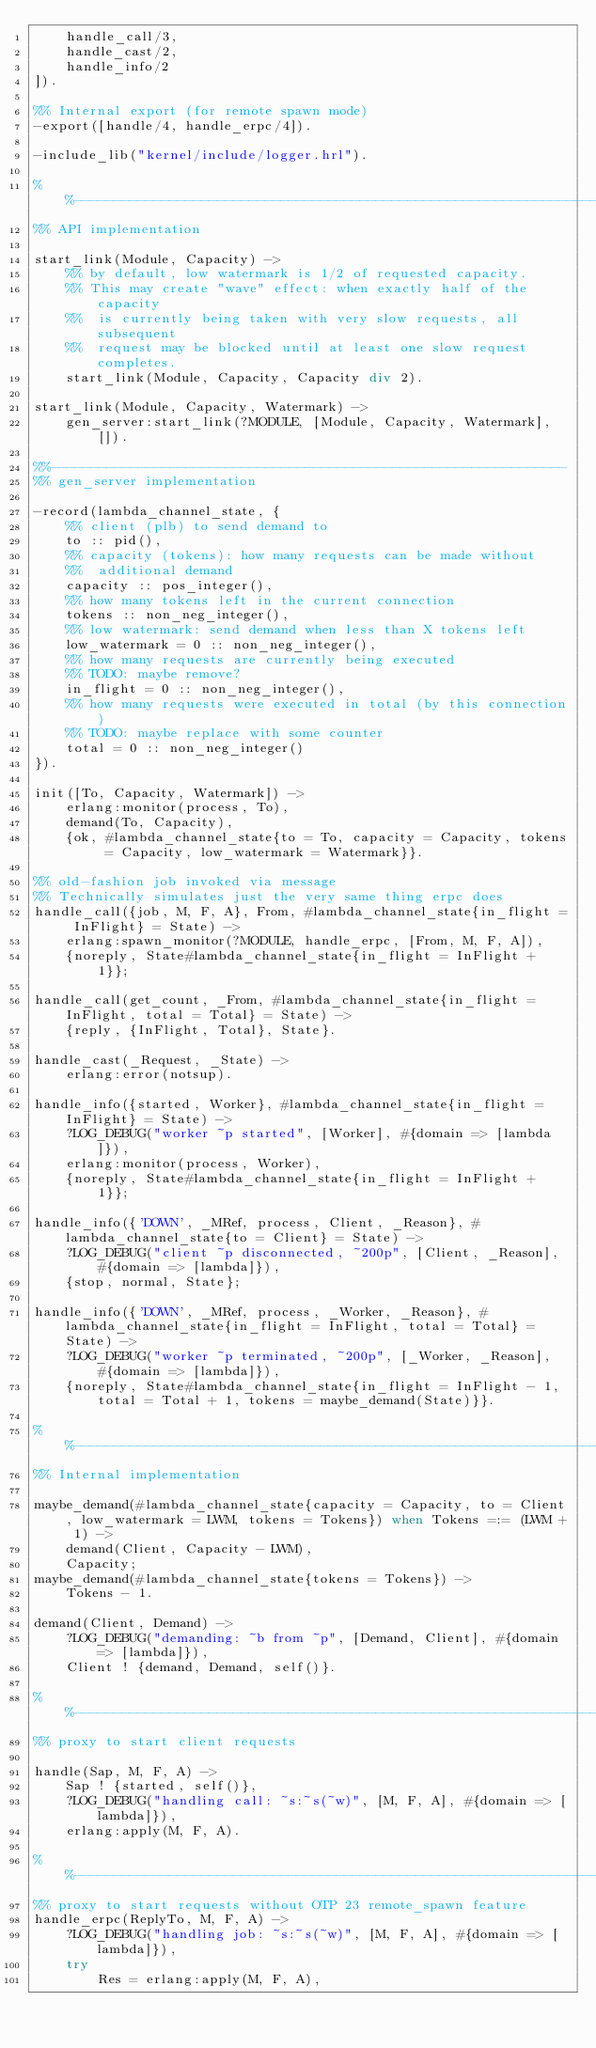<code> <loc_0><loc_0><loc_500><loc_500><_Erlang_>    handle_call/3,
    handle_cast/2,
    handle_info/2
]).

%% Internal export (for remote spawn mode)
-export([handle/4, handle_erpc/4]).

-include_lib("kernel/include/logger.hrl").

%%--------------------------------------------------------------------
%% API implementation

start_link(Module, Capacity) ->
    %% by default, low watermark is 1/2 of requested capacity.
    %% This may create "wave" effect: when exactly half of the capacity
    %%  is currently being taken with very slow requests, all subsequent
    %%  request may be blocked until at least one slow request completes.
    start_link(Module, Capacity, Capacity div 2).

start_link(Module, Capacity, Watermark) ->
    gen_server:start_link(?MODULE, [Module, Capacity, Watermark], []).

%%-----------------------------------------------------------------
%% gen_server implementation

-record(lambda_channel_state, {
    %% client (plb) to send demand to
    to :: pid(),
    %% capacity (tokens): how many requests can be made without
    %%  additional demand
    capacity :: pos_integer(),
    %% how many tokens left in the current connection
    tokens :: non_neg_integer(),
    %% low watermark: send demand when less than X tokens left
    low_watermark = 0 :: non_neg_integer(),
    %% how many requests are currently being executed
    %% TODO: maybe remove?
    in_flight = 0 :: non_neg_integer(),
    %% how many requests were executed in total (by this connection)
    %% TODO: maybe replace with some counter
    total = 0 :: non_neg_integer()
}).

init([To, Capacity, Watermark]) ->
    erlang:monitor(process, To),
    demand(To, Capacity),
    {ok, #lambda_channel_state{to = To, capacity = Capacity, tokens = Capacity, low_watermark = Watermark}}.

%% old-fashion job invoked via message
%% Technically simulates just the very same thing erpc does
handle_call({job, M, F, A}, From, #lambda_channel_state{in_flight = InFlight} = State) ->
    erlang:spawn_monitor(?MODULE, handle_erpc, [From, M, F, A]),
    {noreply, State#lambda_channel_state{in_flight = InFlight + 1}};

handle_call(get_count, _From, #lambda_channel_state{in_flight = InFlight, total = Total} = State) ->
    {reply, {InFlight, Total}, State}.

handle_cast(_Request, _State) ->
    erlang:error(notsup).

handle_info({started, Worker}, #lambda_channel_state{in_flight = InFlight} = State) ->
    ?LOG_DEBUG("worker ~p started", [Worker], #{domain => [lambda]}),
    erlang:monitor(process, Worker),
    {noreply, State#lambda_channel_state{in_flight = InFlight + 1}};

handle_info({'DOWN', _MRef, process, Client, _Reason}, #lambda_channel_state{to = Client} = State) ->
    ?LOG_DEBUG("client ~p disconnected, ~200p", [Client, _Reason], #{domain => [lambda]}),
    {stop, normal, State};

handle_info({'DOWN', _MRef, process, _Worker, _Reason}, #lambda_channel_state{in_flight = InFlight, total = Total} = State) ->
    ?LOG_DEBUG("worker ~p terminated, ~200p", [_Worker, _Reason], #{domain => [lambda]}),
    {noreply, State#lambda_channel_state{in_flight = InFlight - 1, total = Total + 1, tokens = maybe_demand(State)}}.

%%--------------------------------------------------------------------
%% Internal implementation

maybe_demand(#lambda_channel_state{capacity = Capacity, to = Client, low_watermark = LWM, tokens = Tokens}) when Tokens =:= (LWM + 1) ->
    demand(Client, Capacity - LWM),
    Capacity;
maybe_demand(#lambda_channel_state{tokens = Tokens}) ->
    Tokens - 1.

demand(Client, Demand) ->
    ?LOG_DEBUG("demanding: ~b from ~p", [Demand, Client], #{domain => [lambda]}),
    Client ! {demand, Demand, self()}.

%%--------------------------------------------------------------------
%% proxy to start client requests

handle(Sap, M, F, A) ->
    Sap ! {started, self()},
    ?LOG_DEBUG("handling call: ~s:~s(~w)", [M, F, A], #{domain => [lambda]}),
    erlang:apply(M, F, A).

%%--------------------------------------------------------------------
%% proxy to start requests without OTP 23 remote_spawn feature
handle_erpc(ReplyTo, M, F, A) ->
    ?LOG_DEBUG("handling job: ~s:~s(~w)", [M, F, A], #{domain => [lambda]}),
    try
        Res = erlang:apply(M, F, A),</code> 